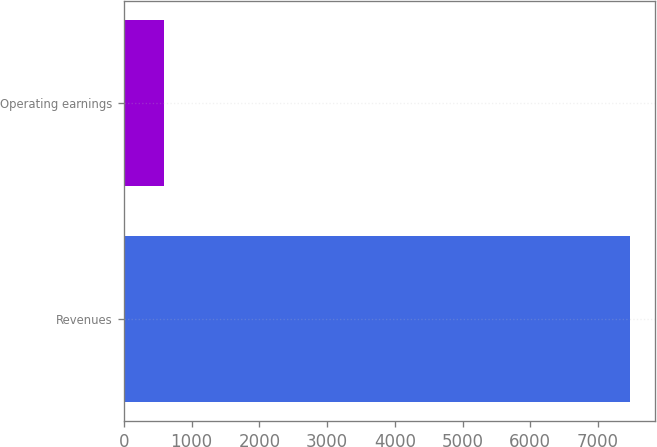Convert chart to OTSL. <chart><loc_0><loc_0><loc_500><loc_500><bar_chart><fcel>Revenues<fcel>Operating earnings<nl><fcel>7471<fcel>595<nl></chart> 